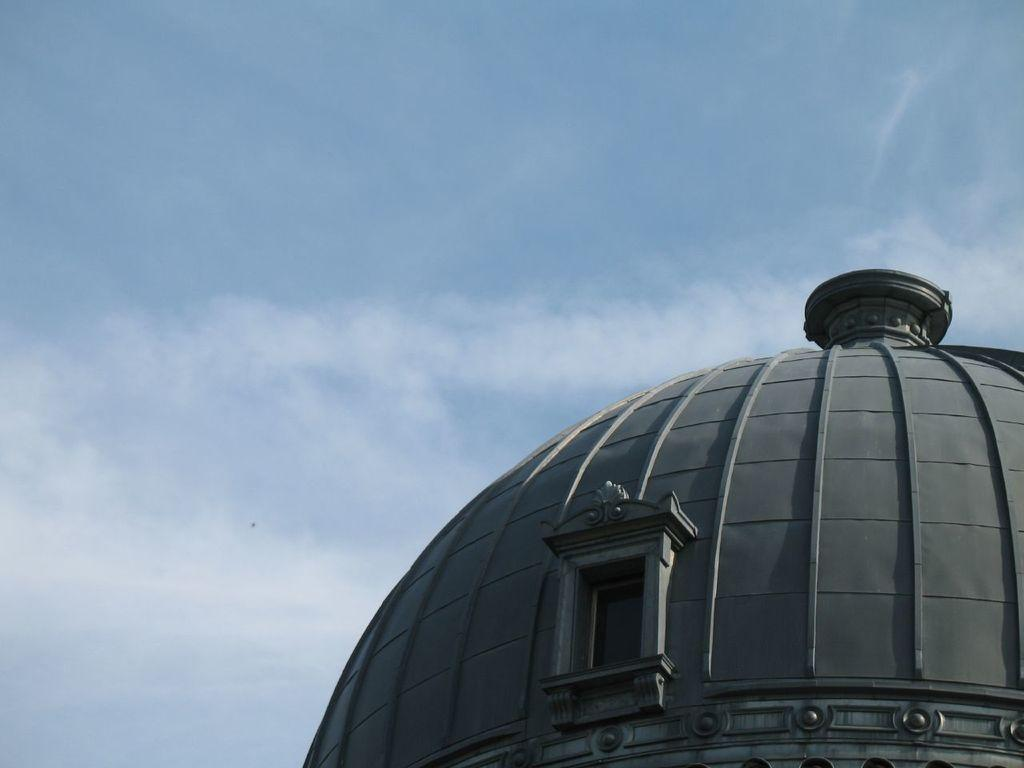What can be seen at the top of the image? The sky is visible in the image. What structure is present in the image? There is a tower in the image. Can you describe the tower's appearance? The top of the tower is visible in the image. Are there any openings in the tower? Yes, there is a window on the tower. What type of health advice is being given through the window on the tower? There is no indication of any health advice being given in the image; it only shows a tower with a window. What type of punishment is being carried out at the top of the tower? There is no indication of any punishment being carried out in the image; it only shows a tower with a window. 